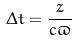<formula> <loc_0><loc_0><loc_500><loc_500>\Delta t = \frac { z } { c \varpi }</formula> 